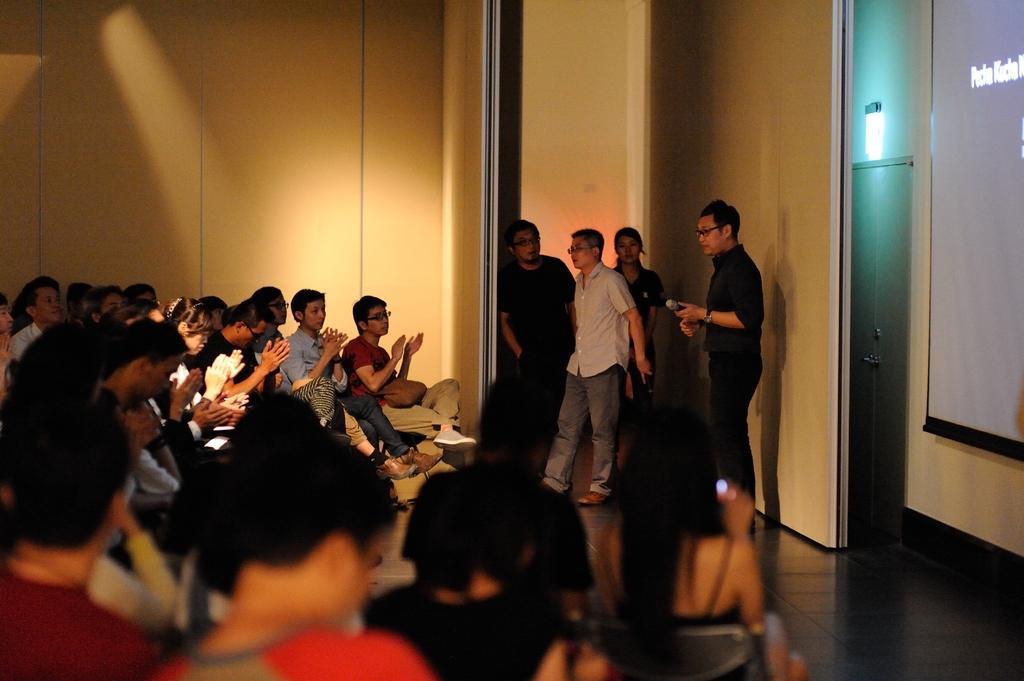Can you describe this image briefly? In this image, we can see some people sitting, at the right side there are some people standing, there is a boy standing and holding a microphone, we can see a wall. 